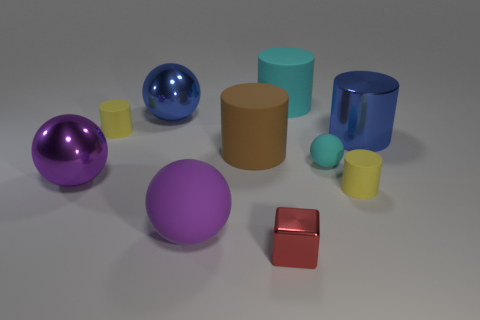There is a blue thing that is the same shape as the small cyan rubber thing; what is it made of?
Your answer should be compact. Metal. There is a large purple matte thing; what shape is it?
Your answer should be very brief. Sphere. There is a large thing that is both behind the blue cylinder and left of the red metal object; what is it made of?
Ensure brevity in your answer.  Metal. What is the shape of the large brown thing that is made of the same material as the small sphere?
Your response must be concise. Cylinder. What size is the cyan cylinder that is made of the same material as the large brown thing?
Offer a terse response. Large. There is a object that is both behind the brown thing and on the right side of the cyan cylinder; what is its shape?
Provide a short and direct response. Cylinder. How big is the cyan object that is in front of the yellow cylinder that is left of the block?
Provide a succinct answer. Small. How many other objects are the same color as the tiny ball?
Make the answer very short. 1. What is the red object made of?
Make the answer very short. Metal. Are there any cyan matte cylinders?
Your response must be concise. Yes. 